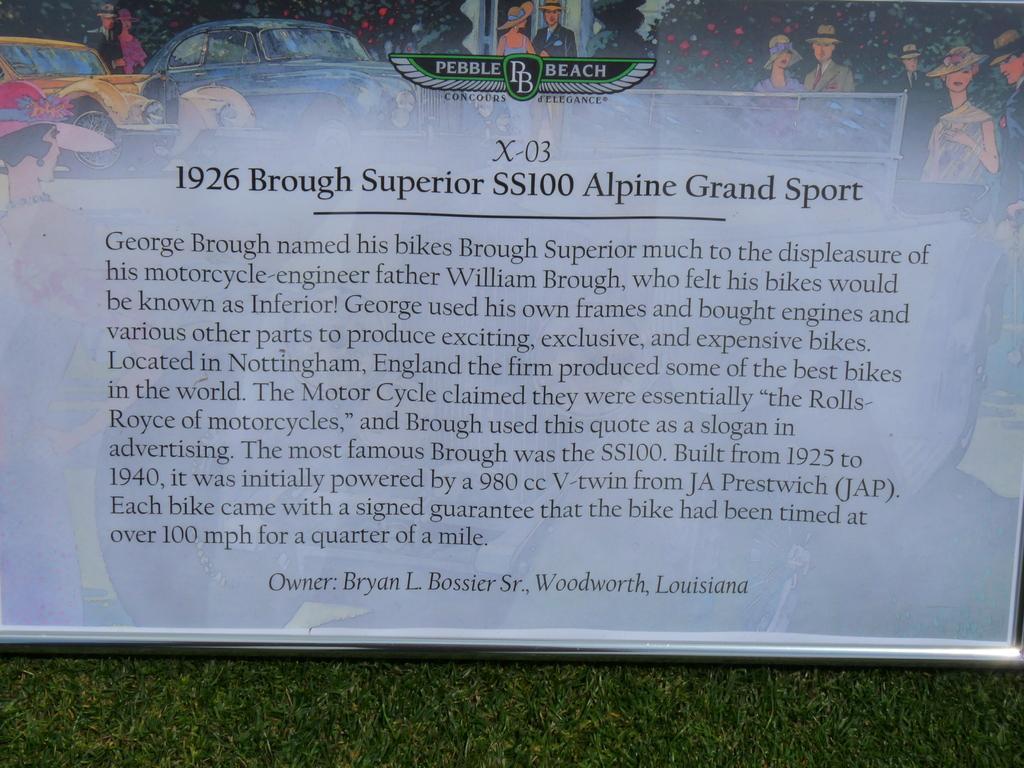Could you give a brief overview of what you see in this image? In this picture I can see there is a banner, there is a picture of cars, people, plants and there is something written at the bottom of the image and it is placed on the grass. 